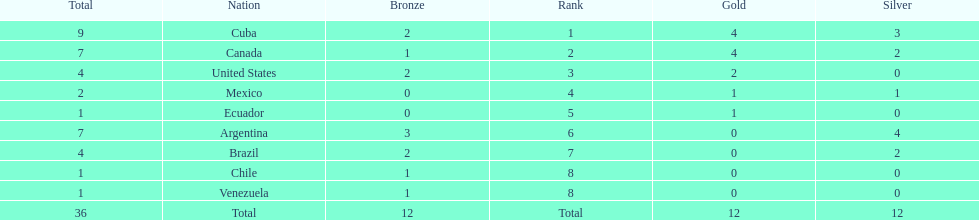How many total medals did brazil received? 4. 